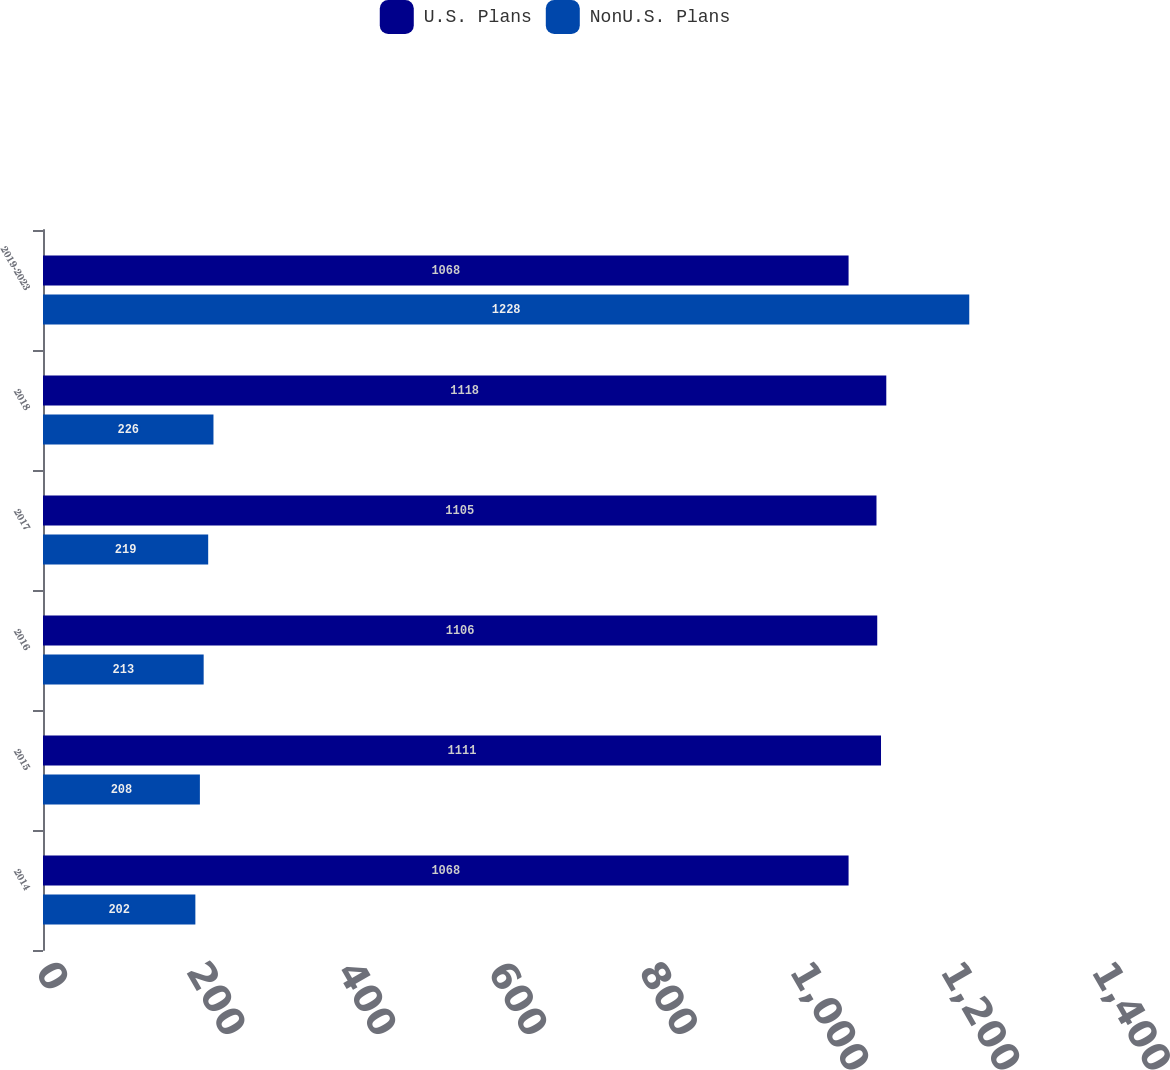Convert chart. <chart><loc_0><loc_0><loc_500><loc_500><stacked_bar_chart><ecel><fcel>2014<fcel>2015<fcel>2016<fcel>2017<fcel>2018<fcel>2019-2023<nl><fcel>U.S. Plans<fcel>1068<fcel>1111<fcel>1106<fcel>1105<fcel>1118<fcel>1068<nl><fcel>NonU.S. Plans<fcel>202<fcel>208<fcel>213<fcel>219<fcel>226<fcel>1228<nl></chart> 